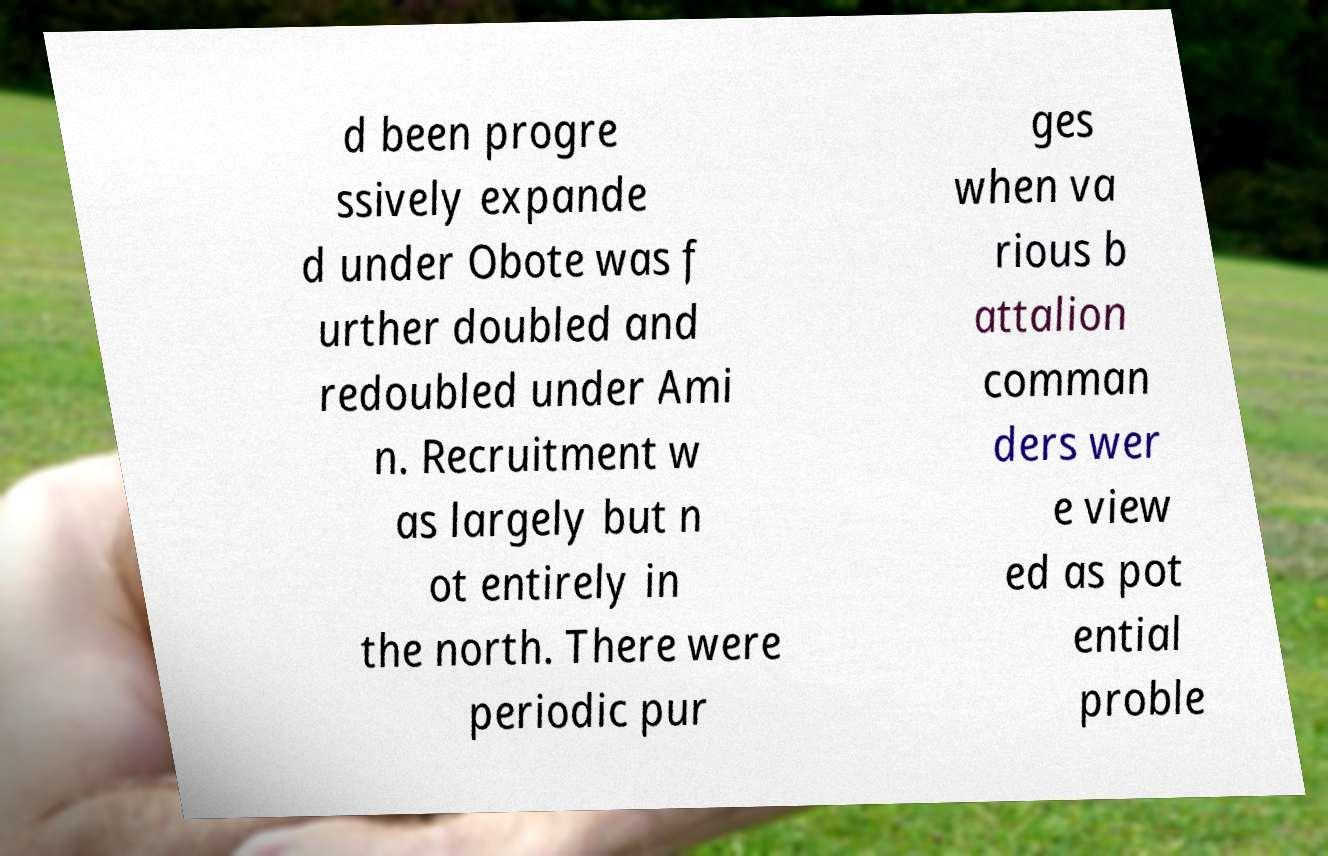Can you read and provide the text displayed in the image?This photo seems to have some interesting text. Can you extract and type it out for me? d been progre ssively expande d under Obote was f urther doubled and redoubled under Ami n. Recruitment w as largely but n ot entirely in the north. There were periodic pur ges when va rious b attalion comman ders wer e view ed as pot ential proble 